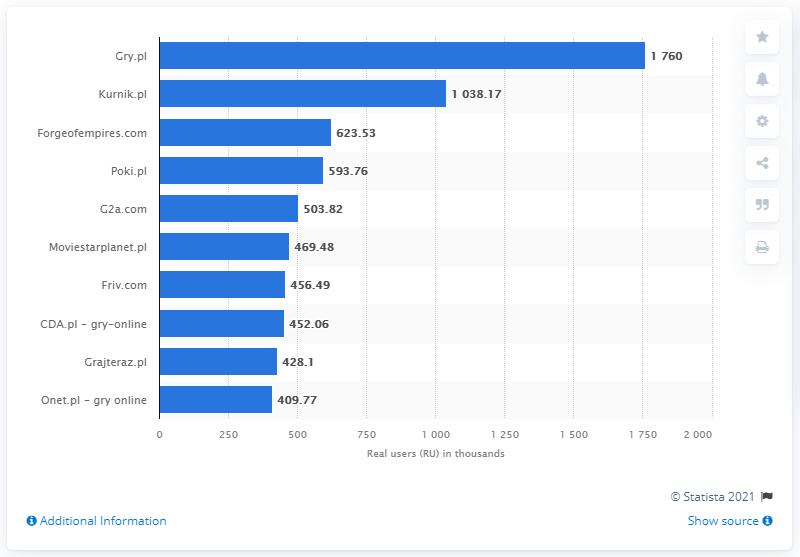How has the user base for the top online gaming website in this chart changed over recent years? While the chart only illustrates the user base for February 2020, typically for such a popular site as Gry.pl, trends could show fluctuations based on new game releases, marketing efforts, and changes in consumer preferences. Analysis of historical data would be required to accurately track the progress over recent years. 